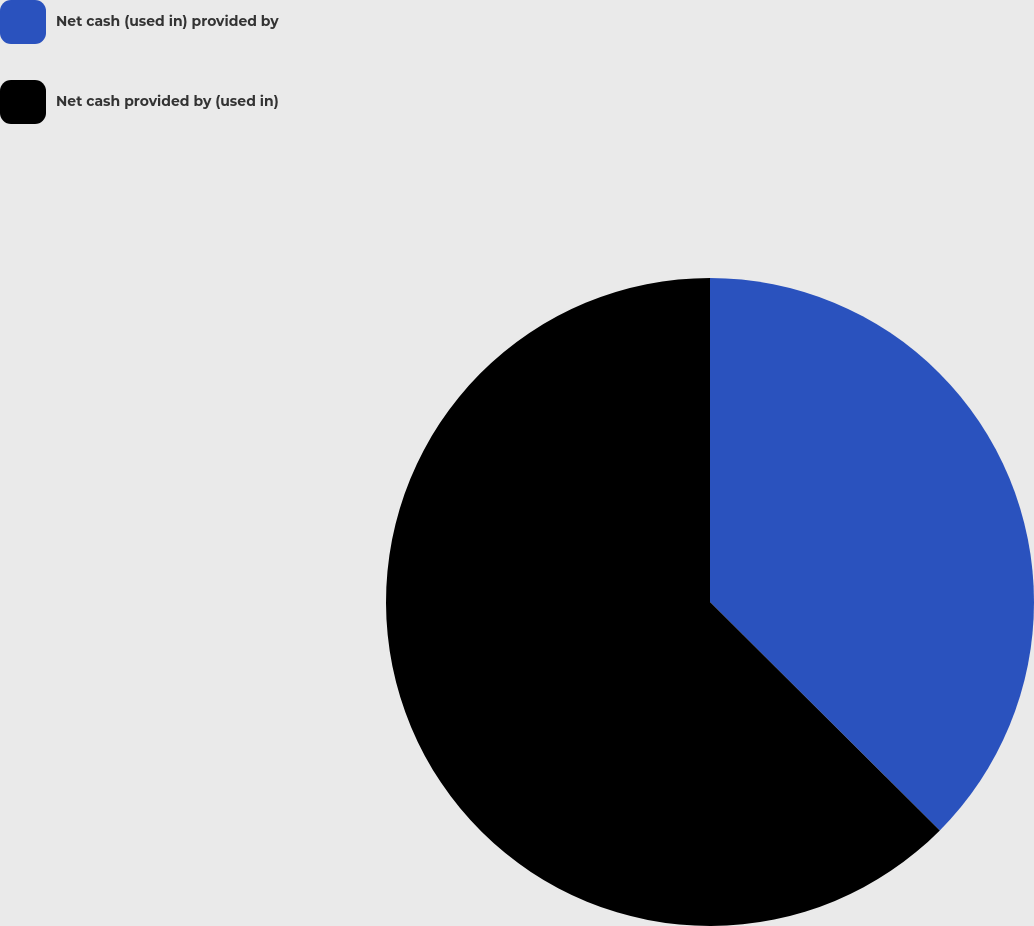<chart> <loc_0><loc_0><loc_500><loc_500><pie_chart><fcel>Net cash (used in) provided by<fcel>Net cash provided by (used in)<nl><fcel>37.45%<fcel>62.55%<nl></chart> 